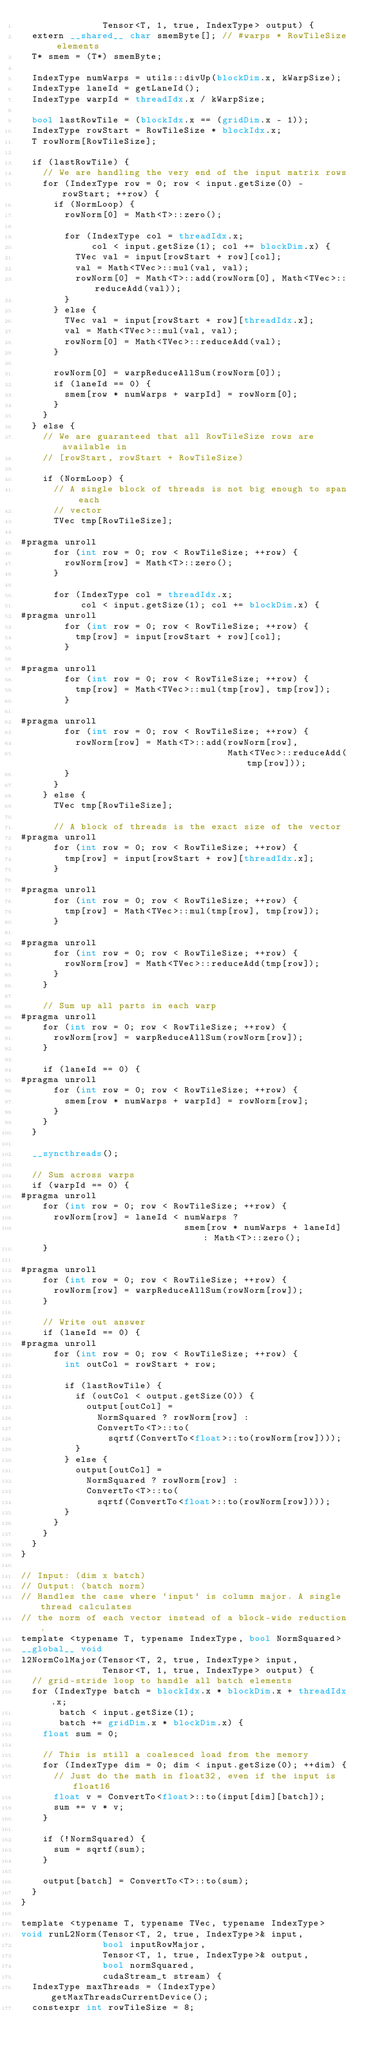Convert code to text. <code><loc_0><loc_0><loc_500><loc_500><_Cuda_>               Tensor<T, 1, true, IndexType> output) {
  extern __shared__ char smemByte[]; // #warps * RowTileSize elements
  T* smem = (T*) smemByte;

  IndexType numWarps = utils::divUp(blockDim.x, kWarpSize);
  IndexType laneId = getLaneId();
  IndexType warpId = threadIdx.x / kWarpSize;

  bool lastRowTile = (blockIdx.x == (gridDim.x - 1));
  IndexType rowStart = RowTileSize * blockIdx.x;
  T rowNorm[RowTileSize];

  if (lastRowTile) {
    // We are handling the very end of the input matrix rows
    for (IndexType row = 0; row < input.getSize(0) - rowStart; ++row) {
      if (NormLoop) {
        rowNorm[0] = Math<T>::zero();

        for (IndexType col = threadIdx.x;
             col < input.getSize(1); col += blockDim.x) {
          TVec val = input[rowStart + row][col];
          val = Math<TVec>::mul(val, val);
          rowNorm[0] = Math<T>::add(rowNorm[0], Math<TVec>::reduceAdd(val));
        }
      } else {
        TVec val = input[rowStart + row][threadIdx.x];
        val = Math<TVec>::mul(val, val);
        rowNorm[0] = Math<TVec>::reduceAdd(val);
      }

      rowNorm[0] = warpReduceAllSum(rowNorm[0]);
      if (laneId == 0) {
        smem[row * numWarps + warpId] = rowNorm[0];
      }
    }
  } else {
    // We are guaranteed that all RowTileSize rows are available in
    // [rowStart, rowStart + RowTileSize)

    if (NormLoop) {
      // A single block of threads is not big enough to span each
      // vector
      TVec tmp[RowTileSize];

#pragma unroll
      for (int row = 0; row < RowTileSize; ++row) {
        rowNorm[row] = Math<T>::zero();
      }

      for (IndexType col = threadIdx.x;
           col < input.getSize(1); col += blockDim.x) {
#pragma unroll
        for (int row = 0; row < RowTileSize; ++row) {
          tmp[row] = input[rowStart + row][col];
        }

#pragma unroll
        for (int row = 0; row < RowTileSize; ++row) {
          tmp[row] = Math<TVec>::mul(tmp[row], tmp[row]);
        }

#pragma unroll
        for (int row = 0; row < RowTileSize; ++row) {
          rowNorm[row] = Math<T>::add(rowNorm[row],
                                      Math<TVec>::reduceAdd(tmp[row]));
        }
      }
    } else {
      TVec tmp[RowTileSize];

      // A block of threads is the exact size of the vector
#pragma unroll
      for (int row = 0; row < RowTileSize; ++row) {
        tmp[row] = input[rowStart + row][threadIdx.x];
      }

#pragma unroll
      for (int row = 0; row < RowTileSize; ++row) {
        tmp[row] = Math<TVec>::mul(tmp[row], tmp[row]);
      }

#pragma unroll
      for (int row = 0; row < RowTileSize; ++row) {
        rowNorm[row] = Math<TVec>::reduceAdd(tmp[row]);
      }
    }

    // Sum up all parts in each warp
#pragma unroll
    for (int row = 0; row < RowTileSize; ++row) {
      rowNorm[row] = warpReduceAllSum(rowNorm[row]);
    }

    if (laneId == 0) {
#pragma unroll
      for (int row = 0; row < RowTileSize; ++row) {
        smem[row * numWarps + warpId] = rowNorm[row];
      }
    }
  }

  __syncthreads();

  // Sum across warps
  if (warpId == 0) {
#pragma unroll
    for (int row = 0; row < RowTileSize; ++row) {
      rowNorm[row] = laneId < numWarps ?
                              smem[row * numWarps + laneId] : Math<T>::zero();
    }

#pragma unroll
    for (int row = 0; row < RowTileSize; ++row) {
      rowNorm[row] = warpReduceAllSum(rowNorm[row]);
    }

    // Write out answer
    if (laneId == 0) {
#pragma unroll
      for (int row = 0; row < RowTileSize; ++row) {
        int outCol = rowStart + row;

        if (lastRowTile) {
          if (outCol < output.getSize(0)) {
            output[outCol] =
              NormSquared ? rowNorm[row] :
              ConvertTo<T>::to(
                sqrtf(ConvertTo<float>::to(rowNorm[row])));
          }
        } else {
          output[outCol] =
            NormSquared ? rowNorm[row] :
            ConvertTo<T>::to(
              sqrtf(ConvertTo<float>::to(rowNorm[row])));
        }
      }
    }
  }
}

// Input: (dim x batch)
// Output: (batch norm)
// Handles the case where `input` is column major. A single thread calculates
// the norm of each vector instead of a block-wide reduction.
template <typename T, typename IndexType, bool NormSquared>
__global__ void
l2NormColMajor(Tensor<T, 2, true, IndexType> input,
               Tensor<T, 1, true, IndexType> output) {
  // grid-stride loop to handle all batch elements
  for (IndexType batch = blockIdx.x * blockDim.x + threadIdx.x;
       batch < input.getSize(1);
       batch += gridDim.x * blockDim.x) {
    float sum = 0;

    // This is still a coalesced load from the memory
    for (IndexType dim = 0; dim < input.getSize(0); ++dim) {
      // Just do the math in float32, even if the input is float16
      float v = ConvertTo<float>::to(input[dim][batch]);
      sum += v * v;
    }

    if (!NormSquared) {
      sum = sqrtf(sum);
    }

    output[batch] = ConvertTo<T>::to(sum);
  }
}

template <typename T, typename TVec, typename IndexType>
void runL2Norm(Tensor<T, 2, true, IndexType>& input,
               bool inputRowMajor,
               Tensor<T, 1, true, IndexType>& output,
               bool normSquared,
               cudaStream_t stream) {
  IndexType maxThreads = (IndexType) getMaxThreadsCurrentDevice();
  constexpr int rowTileSize = 8;
</code> 